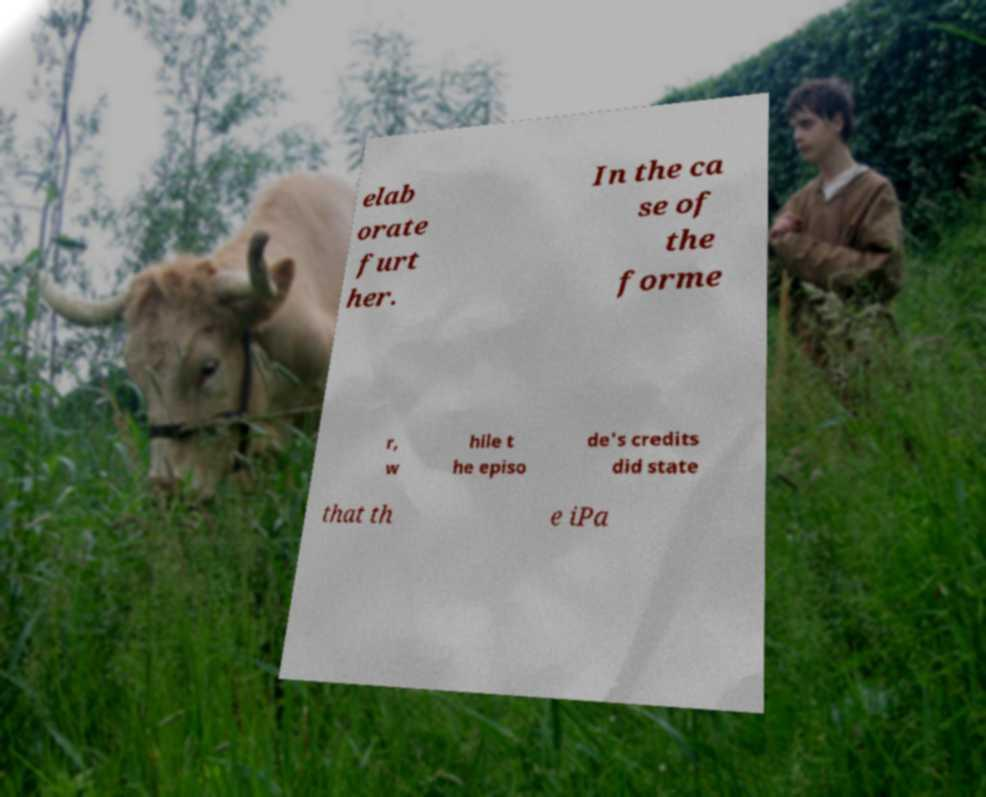I need the written content from this picture converted into text. Can you do that? elab orate furt her. In the ca se of the forme r, w hile t he episo de's credits did state that th e iPa 